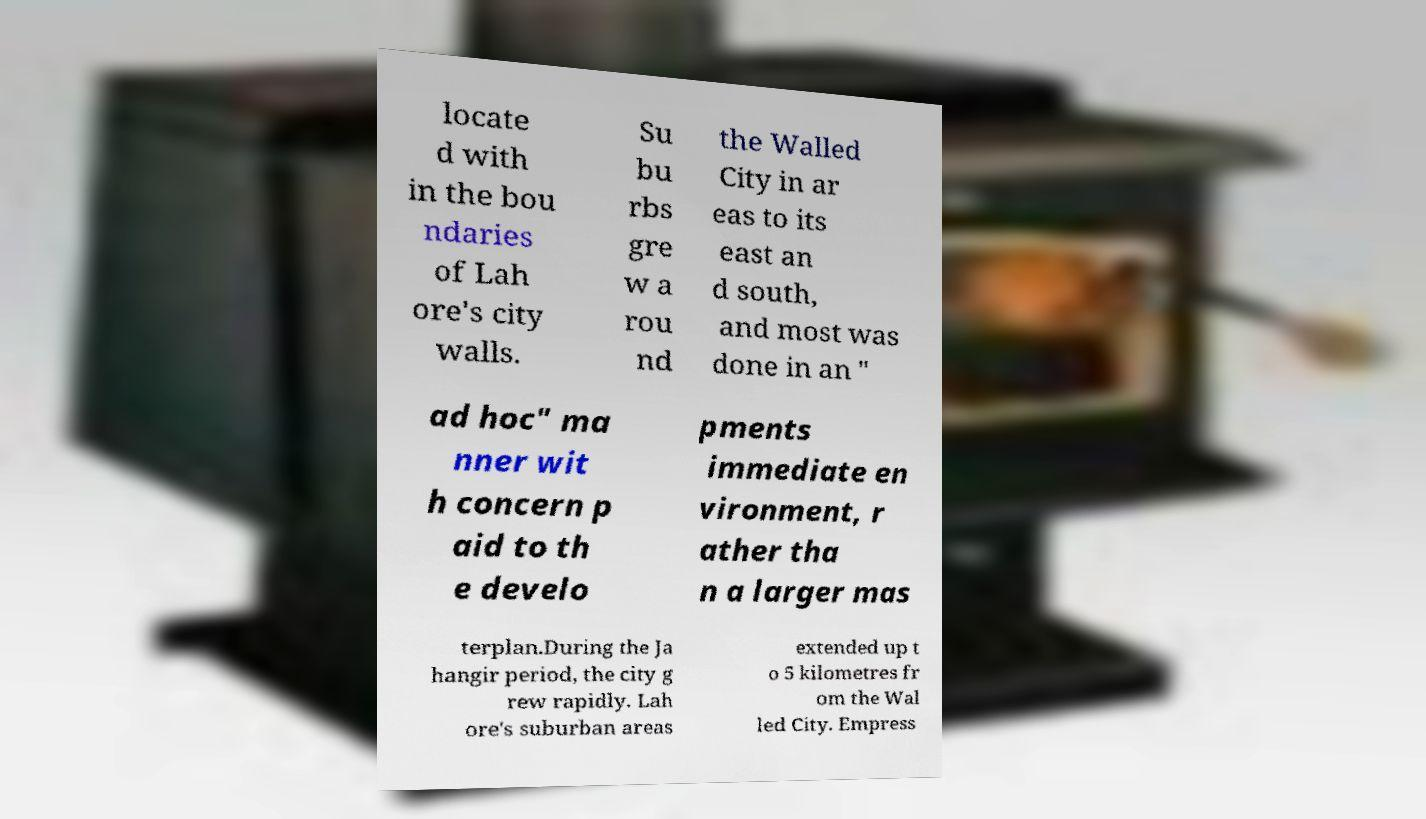I need the written content from this picture converted into text. Can you do that? locate d with in the bou ndaries of Lah ore's city walls. Su bu rbs gre w a rou nd the Walled City in ar eas to its east an d south, and most was done in an " ad hoc" ma nner wit h concern p aid to th e develo pments immediate en vironment, r ather tha n a larger mas terplan.During the Ja hangir period, the city g rew rapidly. Lah ore's suburban areas extended up t o 5 kilometres fr om the Wal led City. Empress 